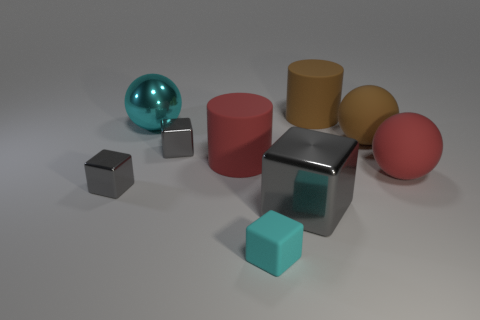Is there anything else that has the same shape as the small cyan matte object?
Offer a very short reply. Yes. What is the small gray block left of the tiny gray object that is behind the big cylinder that is left of the large gray block made of?
Offer a very short reply. Metal. Is there a brown rubber ball that has the same size as the brown cylinder?
Keep it short and to the point. Yes. There is a shiny object that is to the right of the small gray thing right of the cyan metal sphere; what color is it?
Your answer should be very brief. Gray. How many small yellow metal cylinders are there?
Your answer should be very brief. 0. Is the color of the large cube the same as the tiny matte cube?
Provide a succinct answer. No. Is the number of large red matte balls to the left of the large cyan metal sphere less than the number of small metallic objects that are behind the rubber block?
Provide a short and direct response. Yes. What is the color of the large metallic ball?
Your answer should be very brief. Cyan. How many tiny metallic objects are the same color as the large block?
Make the answer very short. 2. Are there any large things to the right of the red cylinder?
Provide a short and direct response. Yes. 